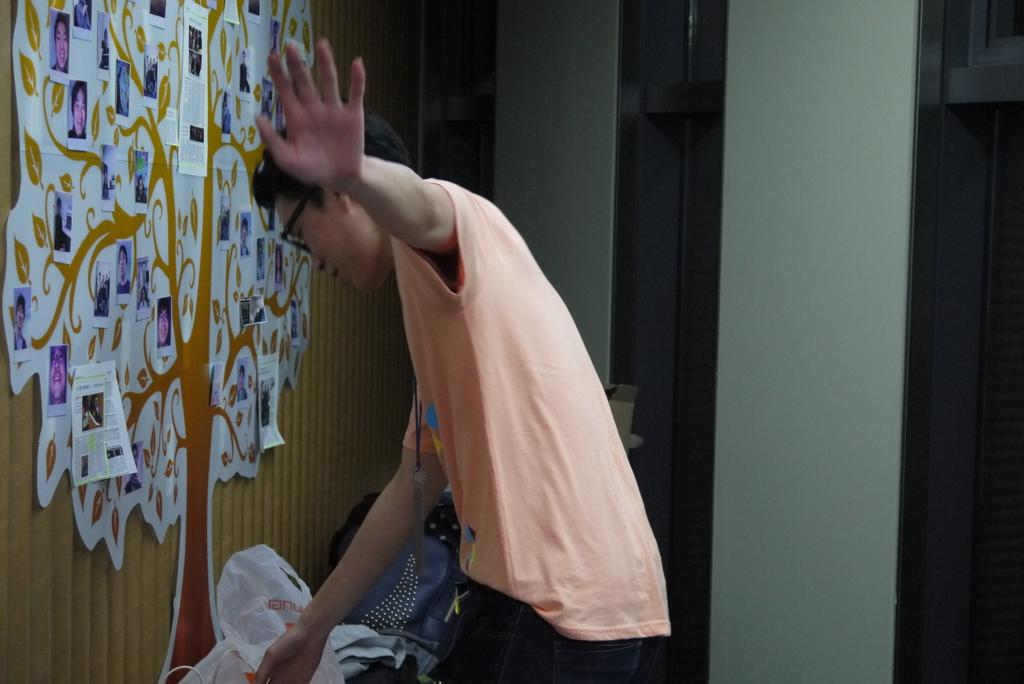Who is present in the image? There is a man in the image. What is the man wearing? The man is wearing a T-shirt. What can be seen on the wall on the left side of the image? There is a tree poster on the wall on the left side of the image. What is located on the left side of the image besides the tree poster? There is a carry bag on the left side of the image. What is displayed on the wall in the image? There are photographs on the wall in the image. What type of screw is holding the roof in place in the image? There is no roof or screw present in the image; it features a man wearing a T-shirt, a tree poster, a carry bag, and photographs on the wall. 